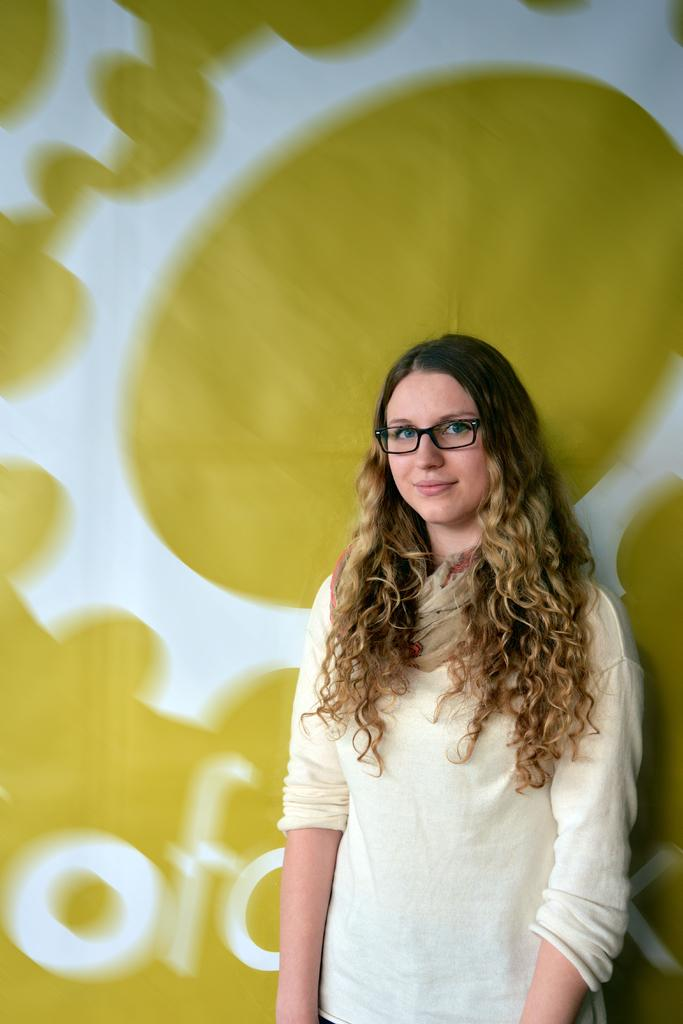Where was the image taken? The image was taken indoors. What can be seen in the background of the image? There is a poster in the background with text and an image on it. Who is the main subject in the image? A girl is standing in the middle of the image. What is the girl's facial expression? The girl has a smiling face. What type of fold can be seen in the girl's clothing in the image? There is no fold visible in the girl's clothing in the image. What is the girl learning in the image? The image does not show the girl learning anything; it only shows her standing with a smiling face. 